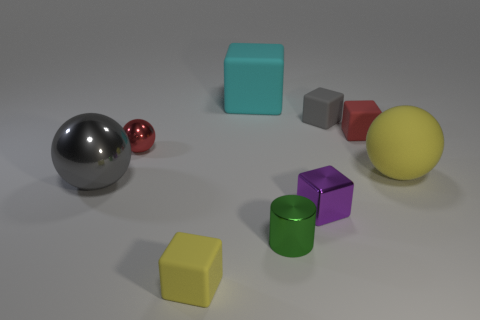Subtract all cyan blocks. How many blocks are left? 4 Subtract all tiny red rubber cubes. How many cubes are left? 4 Subtract 1 balls. How many balls are left? 2 Subtract all yellow blocks. Subtract all green cylinders. How many blocks are left? 4 Add 1 cylinders. How many objects exist? 10 Subtract all spheres. How many objects are left? 6 Add 8 blue shiny cylinders. How many blue shiny cylinders exist? 8 Subtract 1 yellow cubes. How many objects are left? 8 Subtract all tiny blocks. Subtract all small yellow matte things. How many objects are left? 4 Add 9 cylinders. How many cylinders are left? 10 